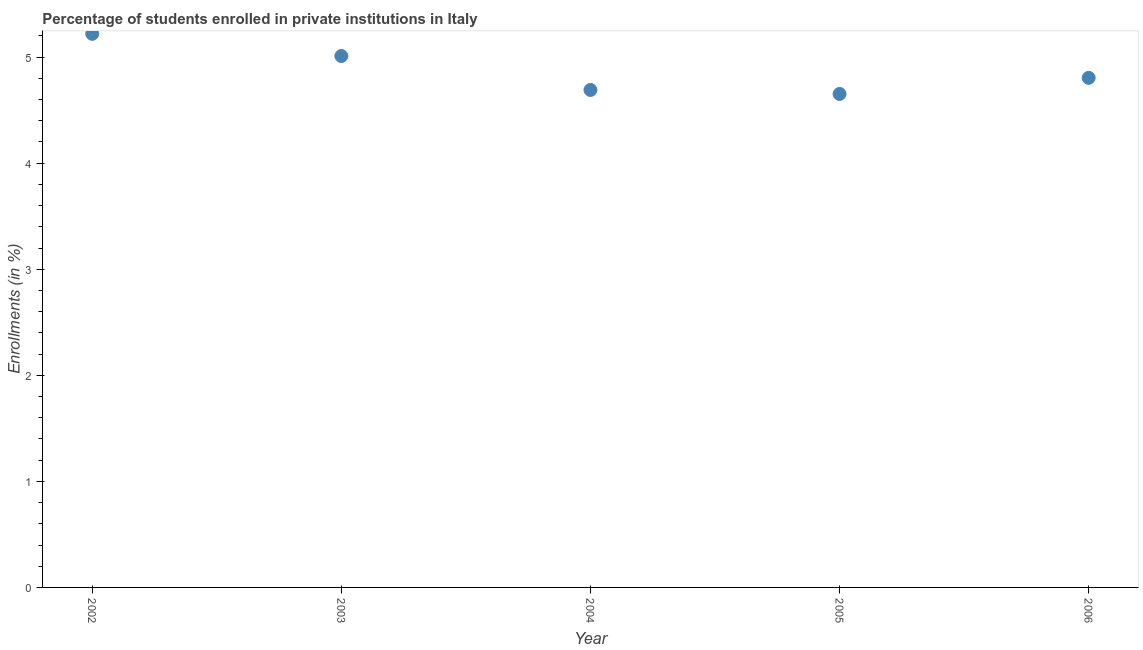What is the enrollments in private institutions in 2003?
Offer a very short reply. 5.01. Across all years, what is the maximum enrollments in private institutions?
Offer a very short reply. 5.22. Across all years, what is the minimum enrollments in private institutions?
Offer a very short reply. 4.65. In which year was the enrollments in private institutions minimum?
Make the answer very short. 2005. What is the sum of the enrollments in private institutions?
Your answer should be very brief. 24.38. What is the difference between the enrollments in private institutions in 2002 and 2004?
Ensure brevity in your answer.  0.53. What is the average enrollments in private institutions per year?
Offer a very short reply. 4.88. What is the median enrollments in private institutions?
Make the answer very short. 4.8. In how many years, is the enrollments in private institutions greater than 3 %?
Give a very brief answer. 5. What is the ratio of the enrollments in private institutions in 2002 to that in 2005?
Make the answer very short. 1.12. Is the enrollments in private institutions in 2002 less than that in 2003?
Your answer should be compact. No. Is the difference between the enrollments in private institutions in 2003 and 2005 greater than the difference between any two years?
Your answer should be very brief. No. What is the difference between the highest and the second highest enrollments in private institutions?
Keep it short and to the point. 0.21. What is the difference between the highest and the lowest enrollments in private institutions?
Provide a short and direct response. 0.57. In how many years, is the enrollments in private institutions greater than the average enrollments in private institutions taken over all years?
Ensure brevity in your answer.  2. Does the enrollments in private institutions monotonically increase over the years?
Provide a short and direct response. No. How many dotlines are there?
Ensure brevity in your answer.  1. How many years are there in the graph?
Make the answer very short. 5. Does the graph contain grids?
Keep it short and to the point. No. What is the title of the graph?
Offer a terse response. Percentage of students enrolled in private institutions in Italy. What is the label or title of the Y-axis?
Your answer should be compact. Enrollments (in %). What is the Enrollments (in %) in 2002?
Offer a terse response. 5.22. What is the Enrollments (in %) in 2003?
Your answer should be very brief. 5.01. What is the Enrollments (in %) in 2004?
Your answer should be very brief. 4.69. What is the Enrollments (in %) in 2005?
Keep it short and to the point. 4.65. What is the Enrollments (in %) in 2006?
Make the answer very short. 4.8. What is the difference between the Enrollments (in %) in 2002 and 2003?
Give a very brief answer. 0.21. What is the difference between the Enrollments (in %) in 2002 and 2004?
Give a very brief answer. 0.53. What is the difference between the Enrollments (in %) in 2002 and 2005?
Your response must be concise. 0.57. What is the difference between the Enrollments (in %) in 2002 and 2006?
Keep it short and to the point. 0.41. What is the difference between the Enrollments (in %) in 2003 and 2004?
Your response must be concise. 0.32. What is the difference between the Enrollments (in %) in 2003 and 2005?
Make the answer very short. 0.36. What is the difference between the Enrollments (in %) in 2003 and 2006?
Provide a short and direct response. 0.21. What is the difference between the Enrollments (in %) in 2004 and 2005?
Make the answer very short. 0.04. What is the difference between the Enrollments (in %) in 2004 and 2006?
Offer a very short reply. -0.11. What is the difference between the Enrollments (in %) in 2005 and 2006?
Offer a very short reply. -0.15. What is the ratio of the Enrollments (in %) in 2002 to that in 2003?
Keep it short and to the point. 1.04. What is the ratio of the Enrollments (in %) in 2002 to that in 2004?
Give a very brief answer. 1.11. What is the ratio of the Enrollments (in %) in 2002 to that in 2005?
Ensure brevity in your answer.  1.12. What is the ratio of the Enrollments (in %) in 2002 to that in 2006?
Your answer should be compact. 1.09. What is the ratio of the Enrollments (in %) in 2003 to that in 2004?
Provide a succinct answer. 1.07. What is the ratio of the Enrollments (in %) in 2003 to that in 2005?
Provide a short and direct response. 1.08. What is the ratio of the Enrollments (in %) in 2003 to that in 2006?
Your response must be concise. 1.04. What is the ratio of the Enrollments (in %) in 2005 to that in 2006?
Your answer should be compact. 0.97. 